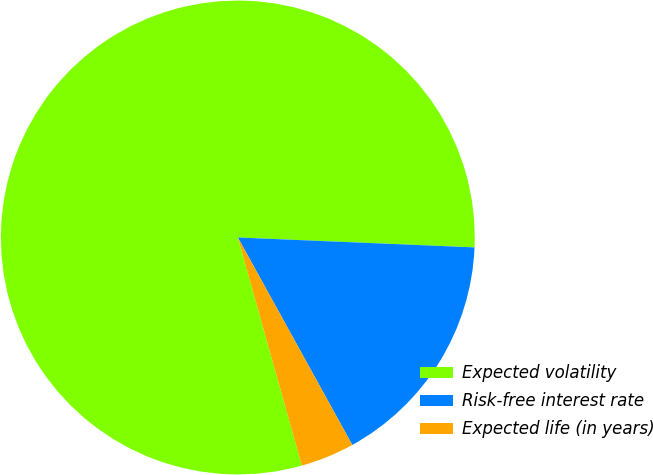<chart> <loc_0><loc_0><loc_500><loc_500><pie_chart><fcel>Expected volatility<fcel>Risk-free interest rate<fcel>Expected life (in years)<nl><fcel>80.03%<fcel>16.31%<fcel>3.67%<nl></chart> 